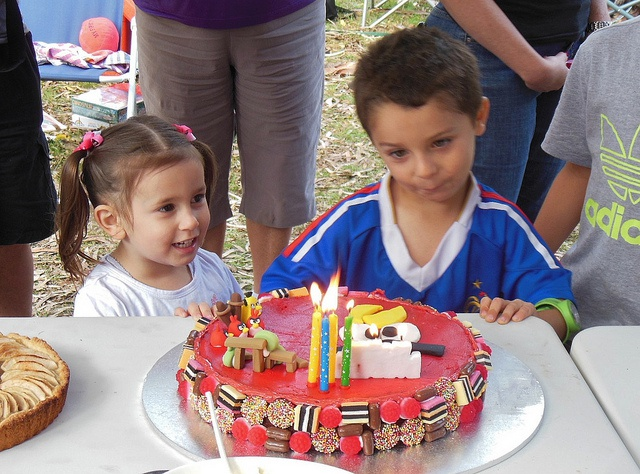Describe the objects in this image and their specific colors. I can see dining table in black, lightgray, salmon, darkgray, and lightpink tones, people in black, brown, blue, and navy tones, cake in black, salmon, lightgray, brown, and lightpink tones, people in black, gray, and darkgray tones, and people in black, brown, tan, lightgray, and gray tones in this image. 